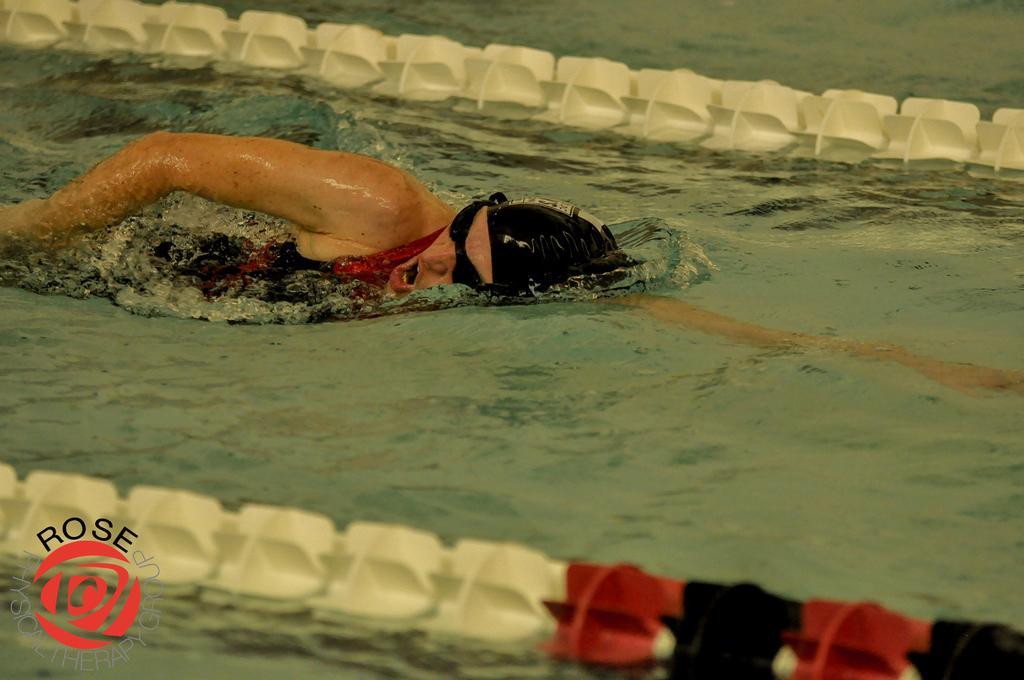How would you summarize this image in a sentence or two? In the image we can see water, in the water we can see a person is swimming and we can see two ropes. 